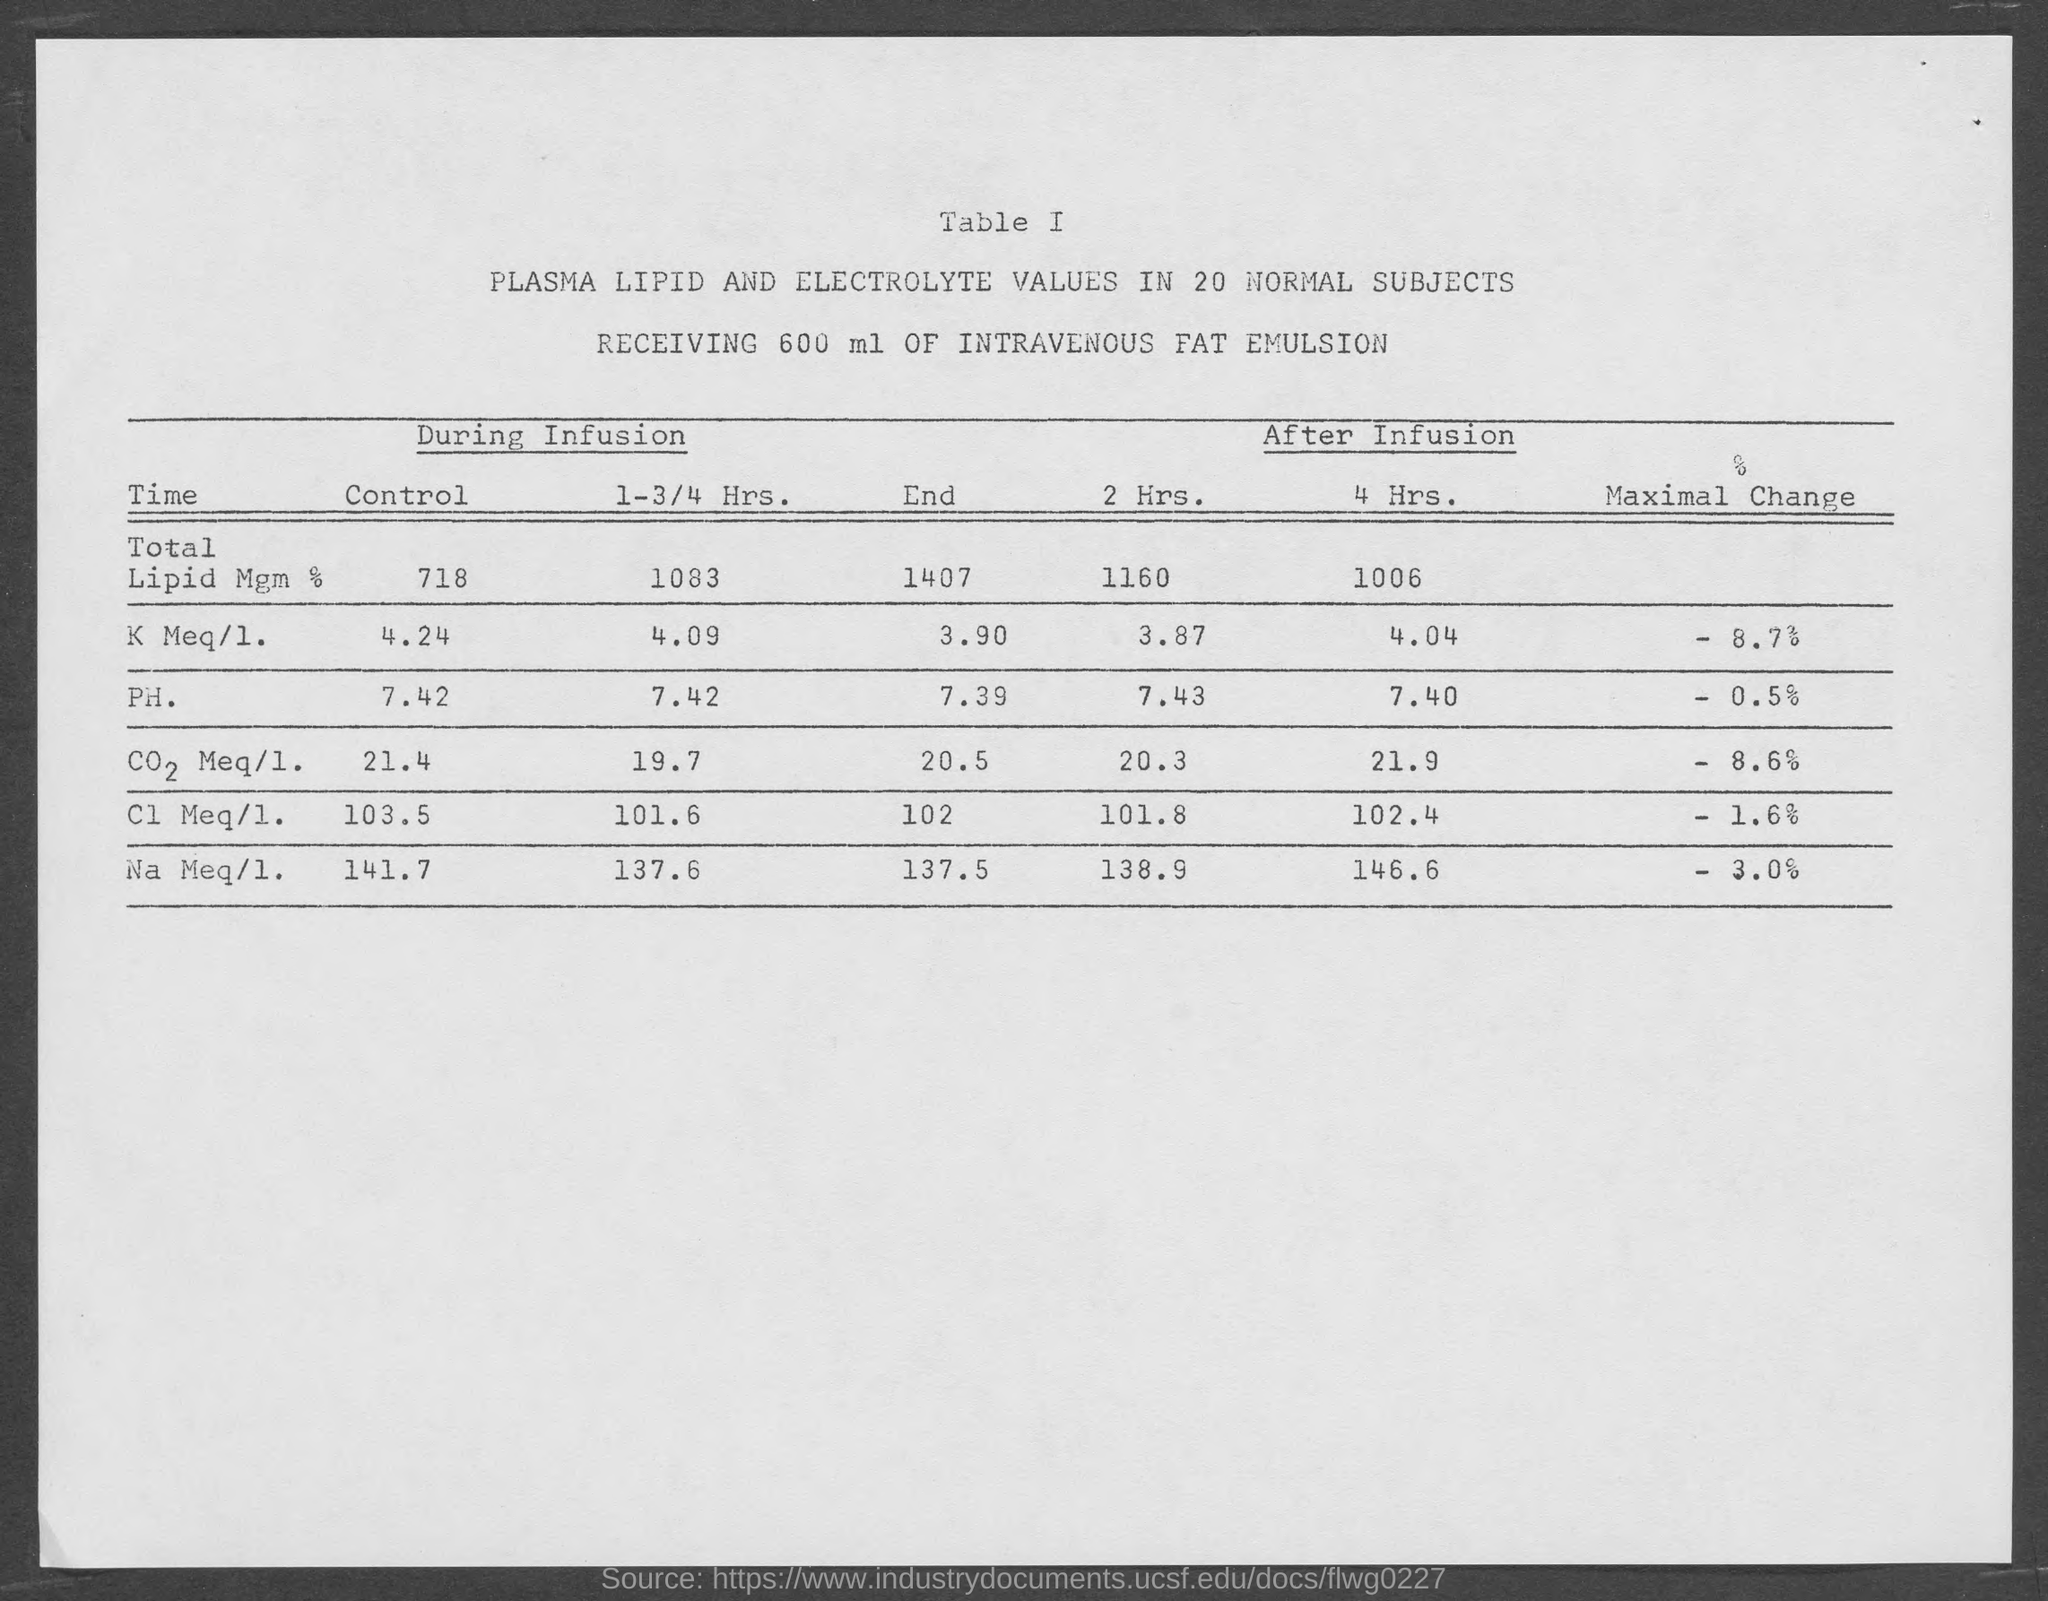What is the total Lipid Mgm % under control during infusion?
Your response must be concise. 718. How much of Intravenous Fat Emulsion was received?
Ensure brevity in your answer.  600 ml. 